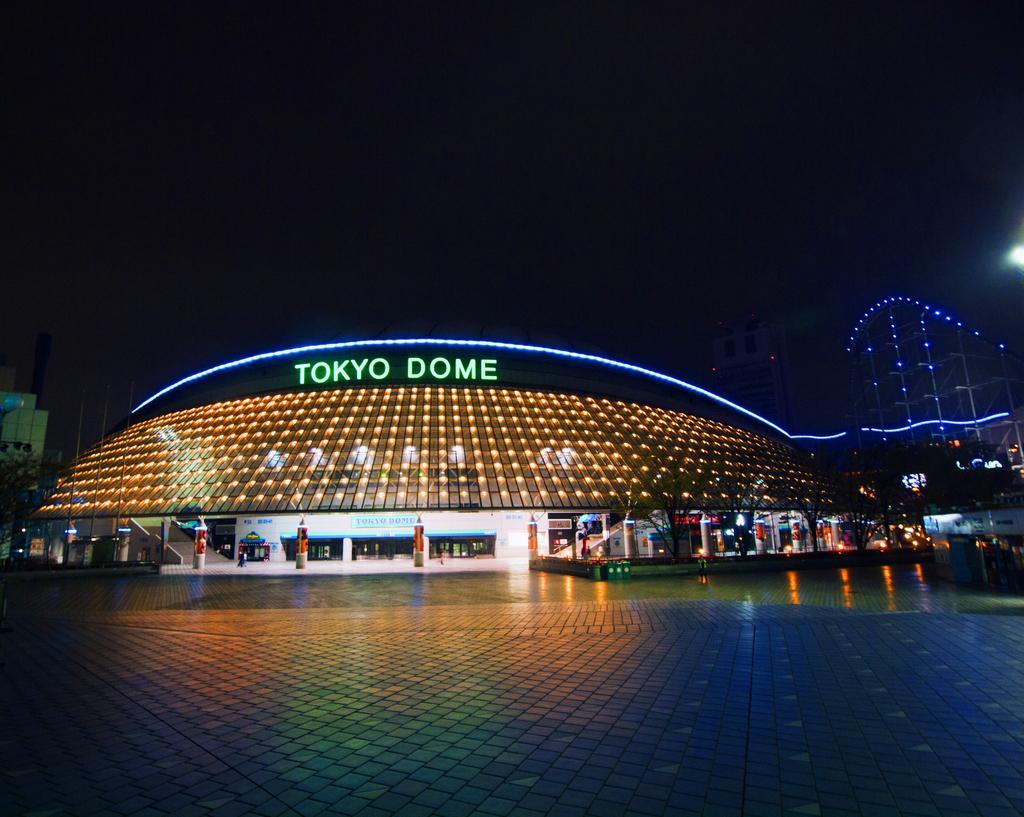In one or two sentences, can you explain what this image depicts? In this image I can see few buildings, number of light, few boards and on these boards I can see something is written. On the both sides of the image I can see few trees and I can also see this image is little bit in dark. 